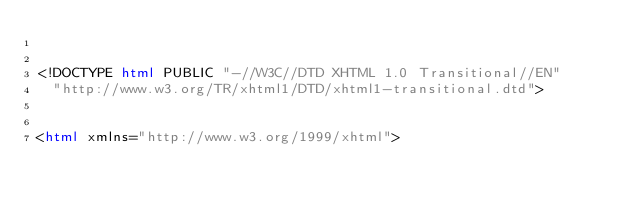<code> <loc_0><loc_0><loc_500><loc_500><_HTML_>

<!DOCTYPE html PUBLIC "-//W3C//DTD XHTML 1.0 Transitional//EN"
  "http://www.w3.org/TR/xhtml1/DTD/xhtml1-transitional.dtd">


<html xmlns="http://www.w3.org/1999/xhtml"></code> 